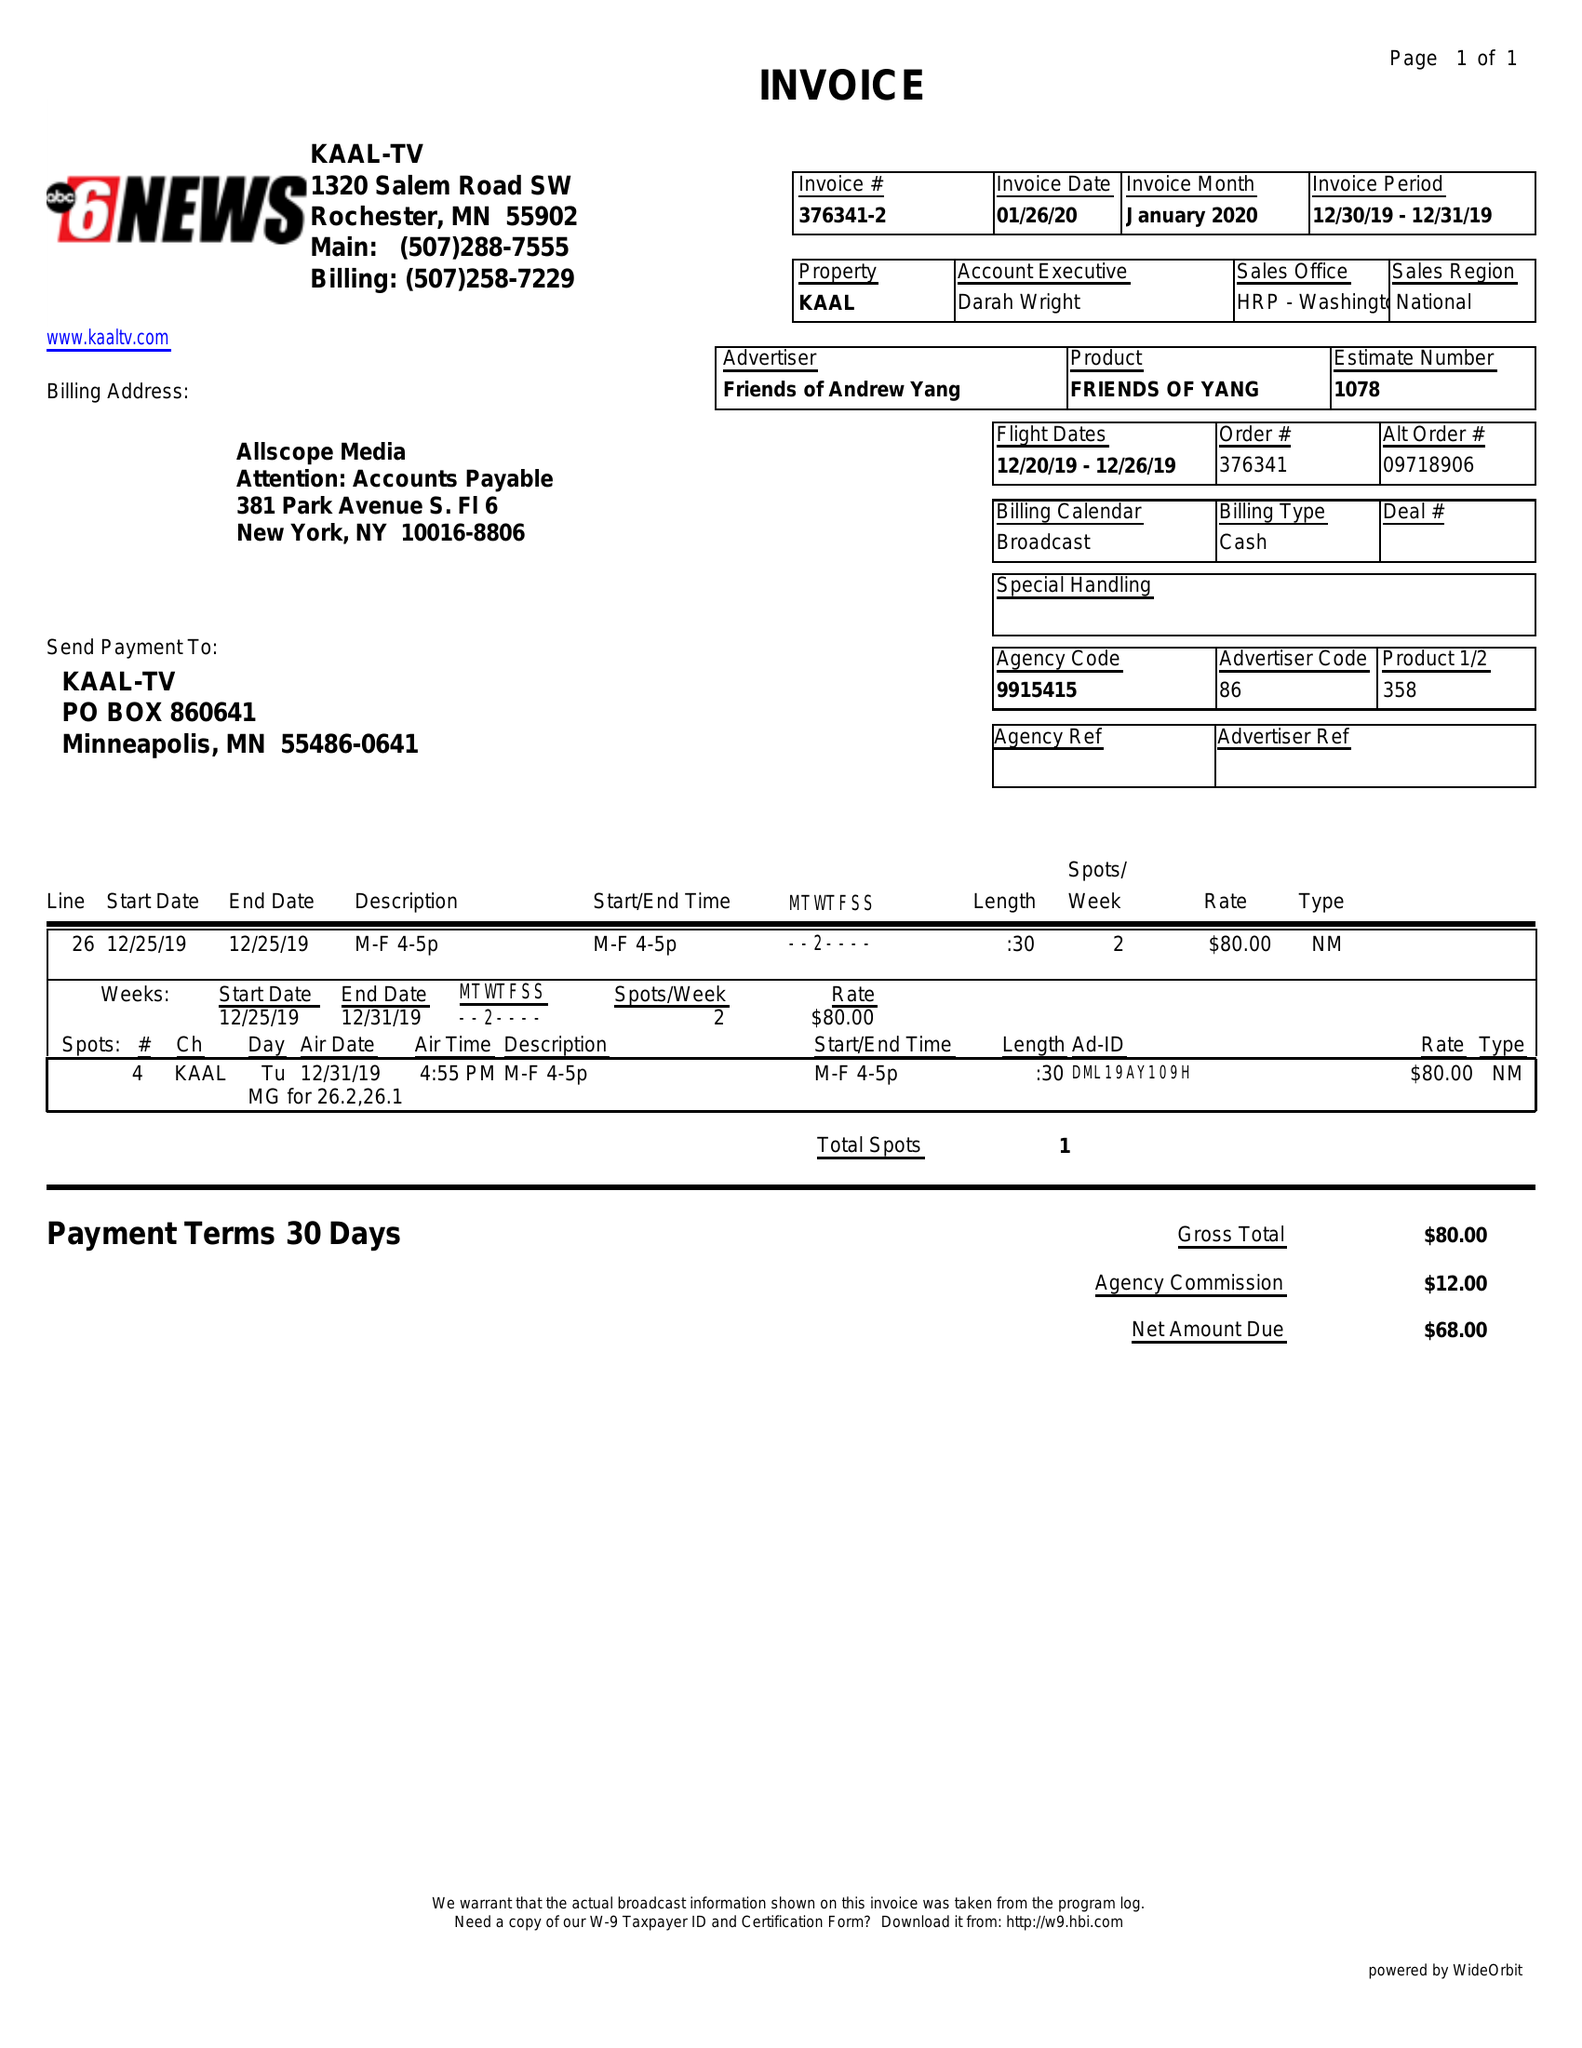What is the value for the gross_amount?
Answer the question using a single word or phrase. 80.00 